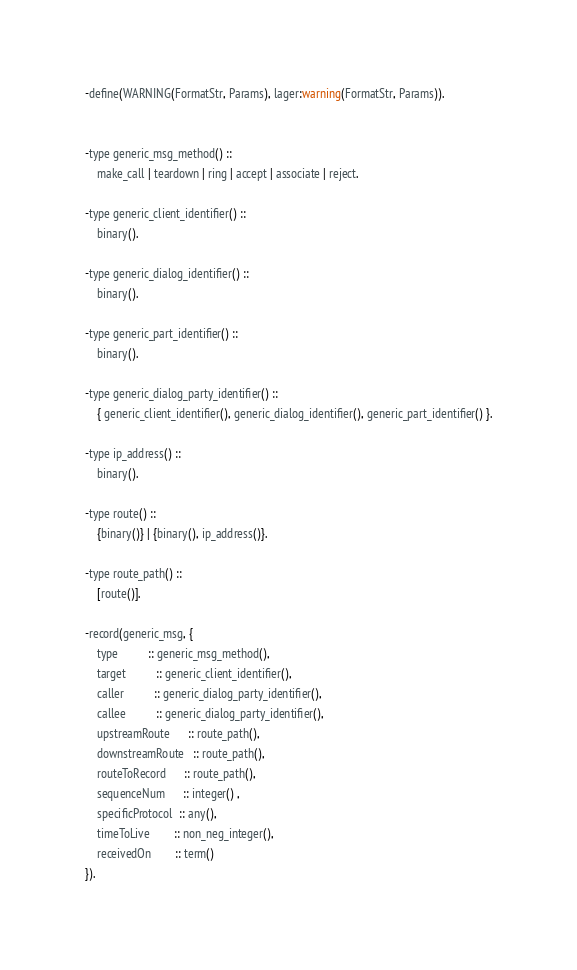<code> <loc_0><loc_0><loc_500><loc_500><_Erlang_>-define(WARNING(FormatStr, Params), lager:warning(FormatStr, Params)).


-type generic_msg_method() ::
	make_call | teardown | ring | accept | associate | reject.

-type generic_client_identifier() ::
	binary().

-type generic_dialog_identifier() ::
	binary().

-type generic_part_identifier() ::
	binary().

-type generic_dialog_party_identifier() ::
	{ generic_client_identifier(), generic_dialog_identifier(), generic_part_identifier() }.

-type ip_address() ::
	binary().

-type route() ::
	{binary()} | {binary(), ip_address()}.

-type route_path() ::
	[route()].

-record(generic_msg, {      
	type 		  :: generic_msg_method(),
	target 		  :: generic_client_identifier(),
	caller 		  :: generic_dialog_party_identifier(),
	callee 		  :: generic_dialog_party_identifier(),
	upstreamRoute  	  :: route_path(),
	downstreamRoute   :: route_path(),
	routeToRecord 	  :: route_path(),
	sequenceNum	  :: integer() ,
	specificProtocol  :: any(),
	timeToLive 		:: non_neg_integer(),
	receivedOn		:: term()
}).

</code> 